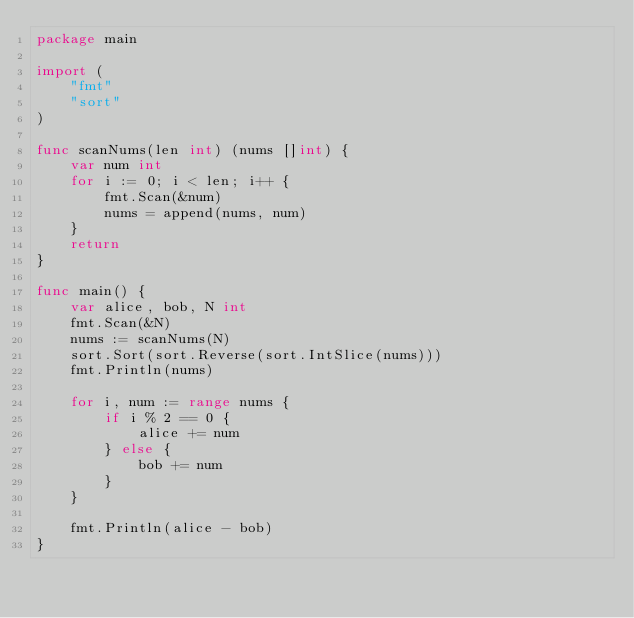Convert code to text. <code><loc_0><loc_0><loc_500><loc_500><_Go_>package main

import (
	"fmt"
	"sort"
)

func scanNums(len int) (nums []int) {
	var num int
	for i := 0; i < len; i++ {
		fmt.Scan(&num)
		nums = append(nums, num)
	}
	return
}

func main() {
	var alice, bob, N int
	fmt.Scan(&N)
	nums := scanNums(N)
	sort.Sort(sort.Reverse(sort.IntSlice(nums)))
	fmt.Println(nums)

	for i, num := range nums {
		if i % 2 == 0 {
			alice += num
		} else {
			bob += num
		}
	}

	fmt.Println(alice - bob)
}</code> 